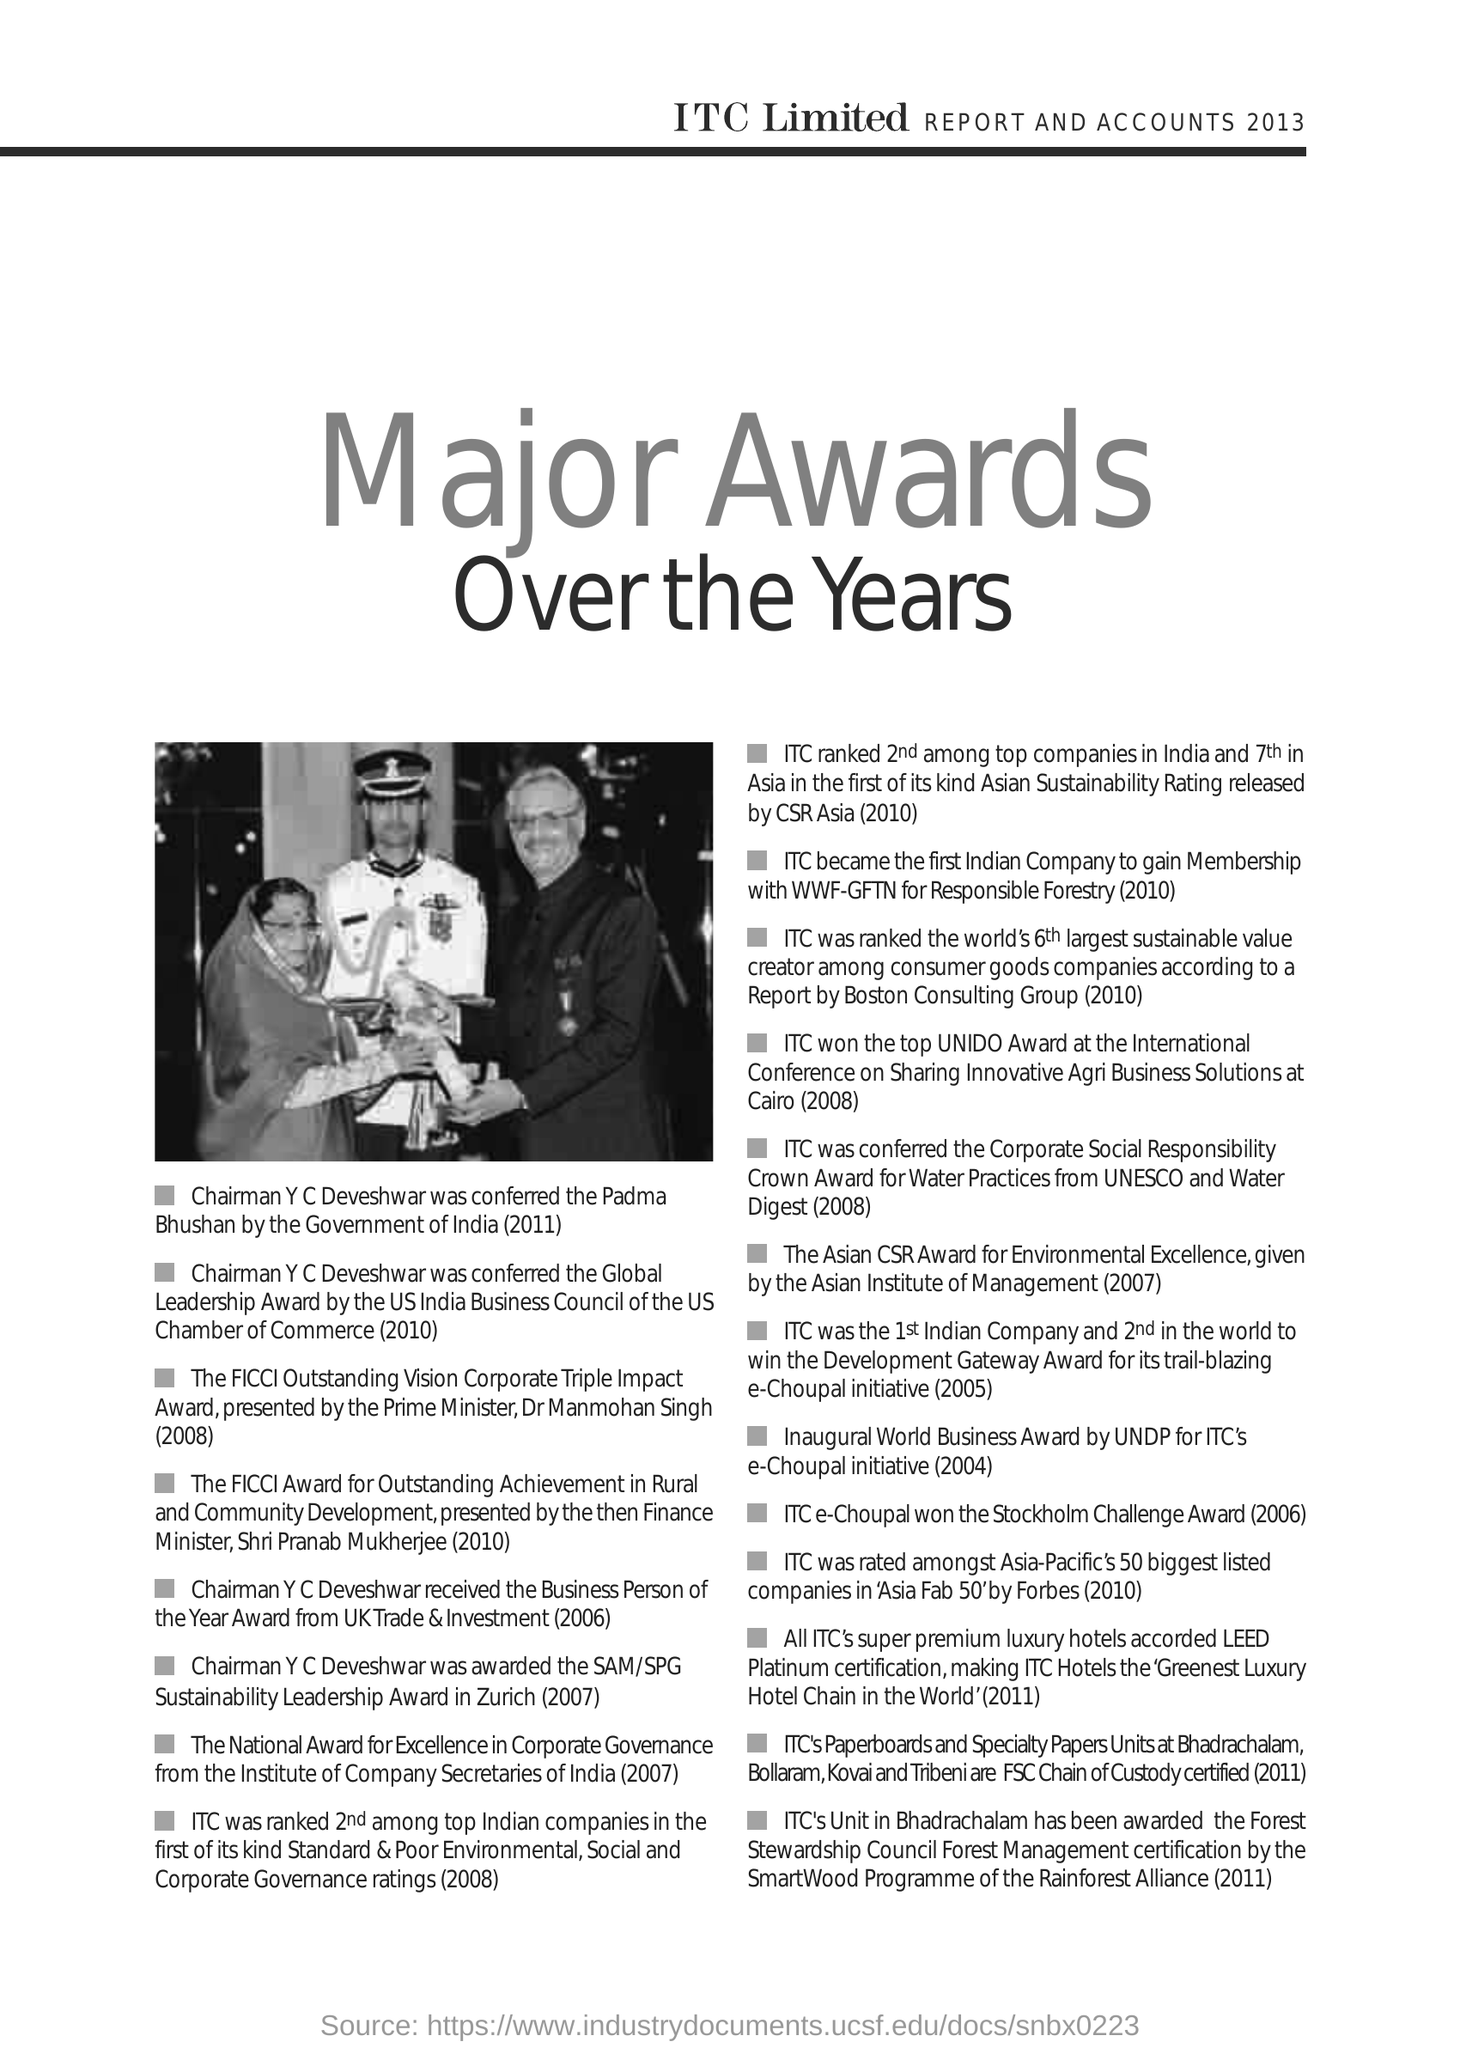Mention a couple of crucial points in this snapshot. The SAM/SPG Sustainability Leadership Award was awarded to Chairman Y C Deveshwar in Zurich in 2007. ITC e-Choupal was awarded the Stockholm Challenge Award in 2006. 